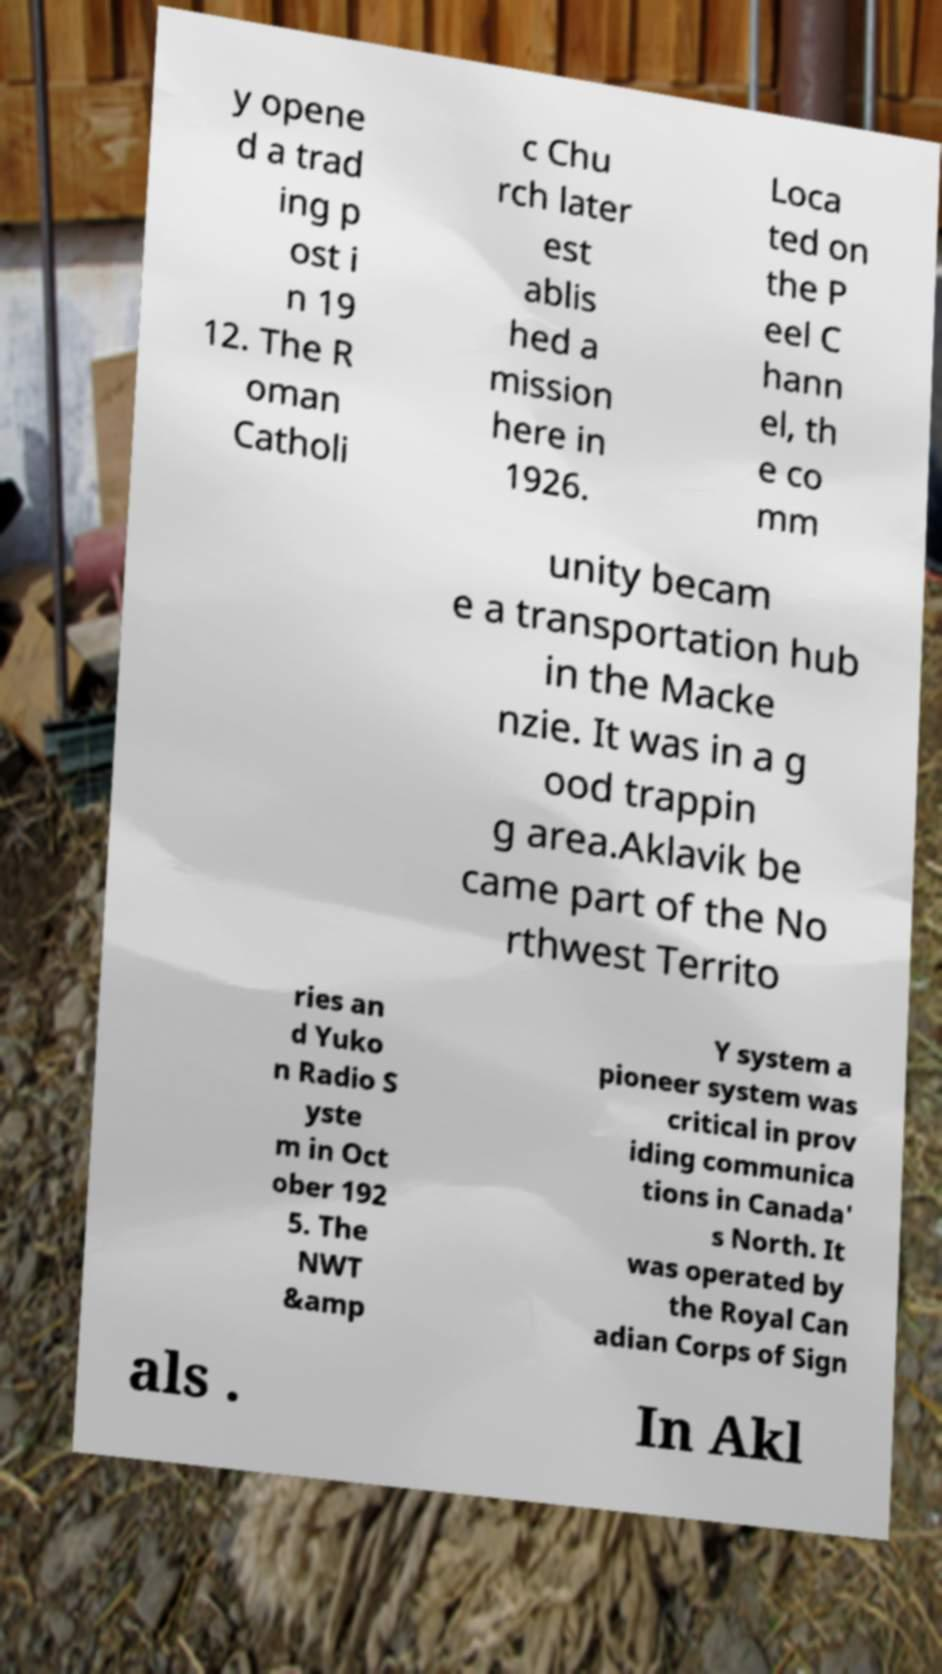Could you extract and type out the text from this image? y opene d a trad ing p ost i n 19 12. The R oman Catholi c Chu rch later est ablis hed a mission here in 1926. Loca ted on the P eel C hann el, th e co mm unity becam e a transportation hub in the Macke nzie. It was in a g ood trappin g area.Aklavik be came part of the No rthwest Territo ries an d Yuko n Radio S yste m in Oct ober 192 5. The NWT &amp Y system a pioneer system was critical in prov iding communica tions in Canada' s North. It was operated by the Royal Can adian Corps of Sign als . In Akl 